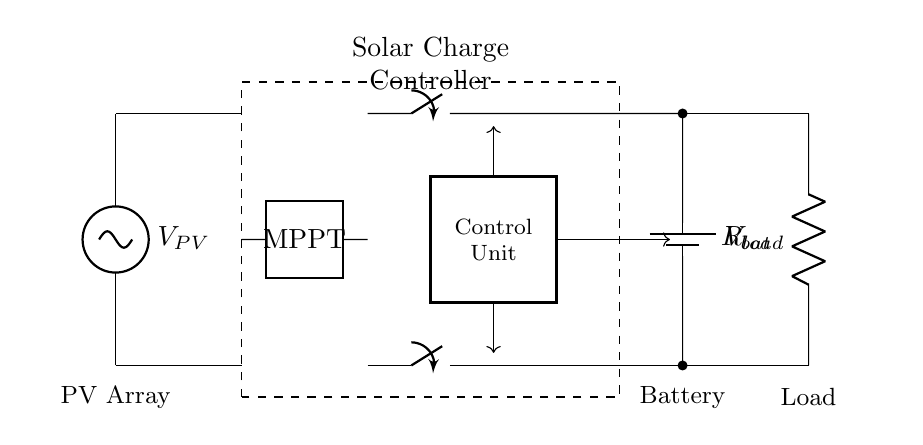What is the voltage source in this circuit? The voltage source is the solar panel, denoted by V_PV, which provides the initial power to the system.
Answer: V_PV What component regulates the charging of the battery? The component that regulates the charging of the battery is the solar charge controller, which includes an MPPT (Maximum Power Point Tracking) module to optimize energy output.
Answer: Solar Charge Controller How many switches are present in the circuit? There are two switches in the circuit, one connected to the charging path and another to the load connection, allowing control over battery charging and load usage.
Answer: Two What is the purpose of the control unit in the circuit? The control unit in the circuit manages the operation of the solar charge controller and ensures proper functioning between the solar panel, battery, and load based on the energy requirements.
Answer: Manages operations Which component is connected to the load? The load is connected to a resistor (R_load) that represents the device or appliance using power from the battery, linking the battery and the load directly.
Answer: Resistor What does MBPT do in this circuit? MPPT optimizes the power output from the solar panel by adjusting the electrical operating point of the modules, significantly improving solar energy conversion efficiency.
Answer: Optimizes power output What is the voltage source for the storage element? The storage element is the battery, which is denoted as V_bat and stores energy collected by the solar panel through the charge controller.
Answer: V_bat 